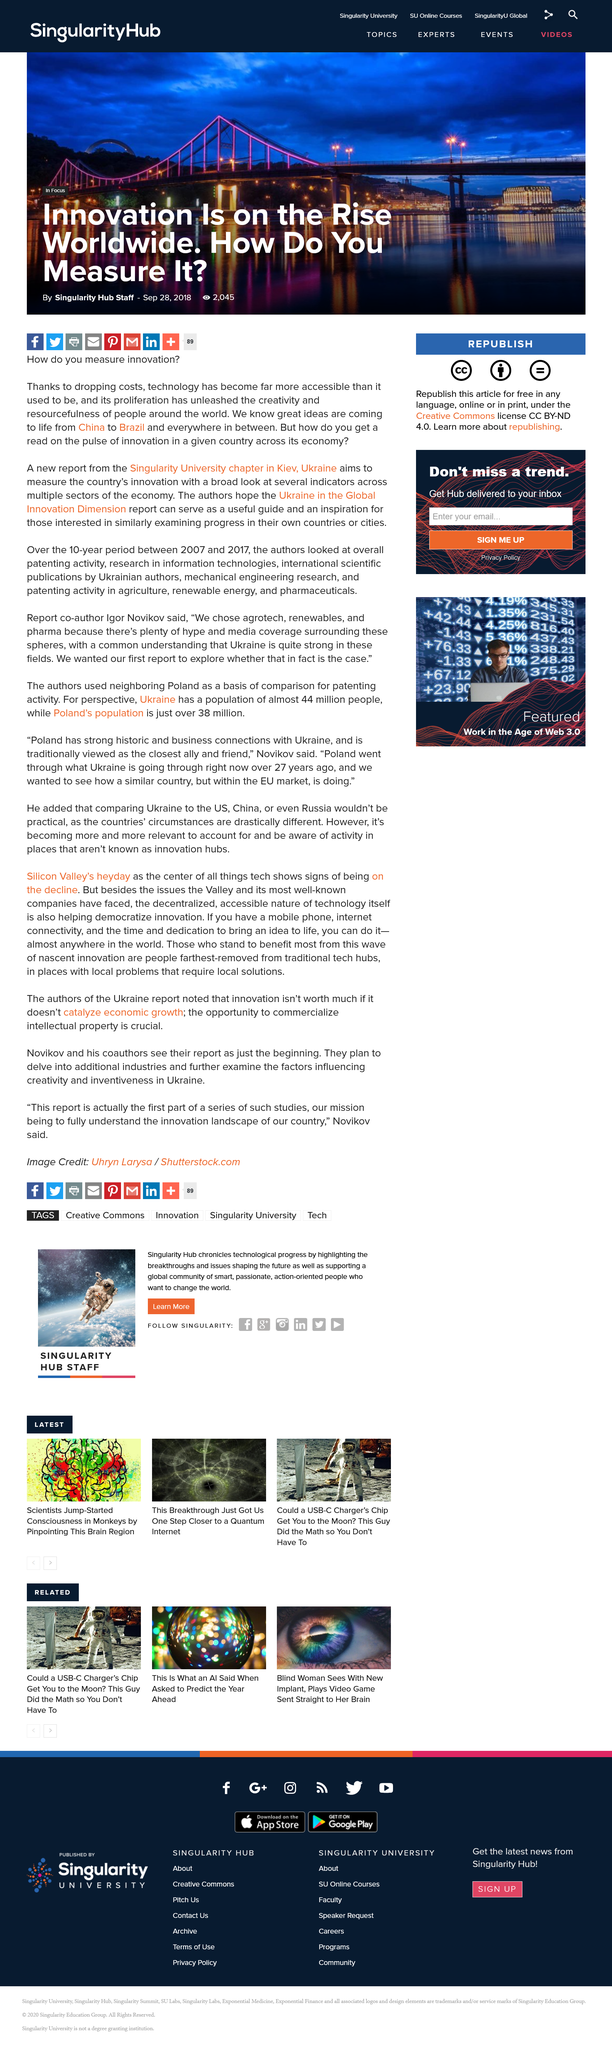Draw attention to some important aspects in this diagram. The "Ukraine in the Global Innovation Dimension" report is intended to be a comprehensive guide and source of inspiration for those interested in studying and analyzing the progress of their own countries or cities. Technology has become more accessible due to the significant decline in its costs, which is one of the primary reasons for this development. On September 28, 2018, the Singularity University chapter in Kiev, Ukraine released a report titled "Innovation is on the rise worldwide. How do you measure it? 